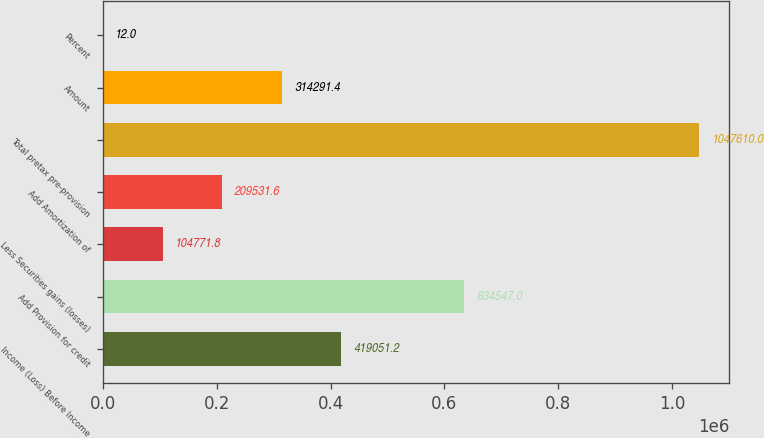<chart> <loc_0><loc_0><loc_500><loc_500><bar_chart><fcel>Income (Loss) Before Income<fcel>Add Provision for credit<fcel>Less Securities gains (losses)<fcel>Add Amortization of<fcel>Total pretax pre-provision<fcel>Amount<fcel>Percent<nl><fcel>419051<fcel>634547<fcel>104772<fcel>209532<fcel>1.04761e+06<fcel>314291<fcel>12<nl></chart> 